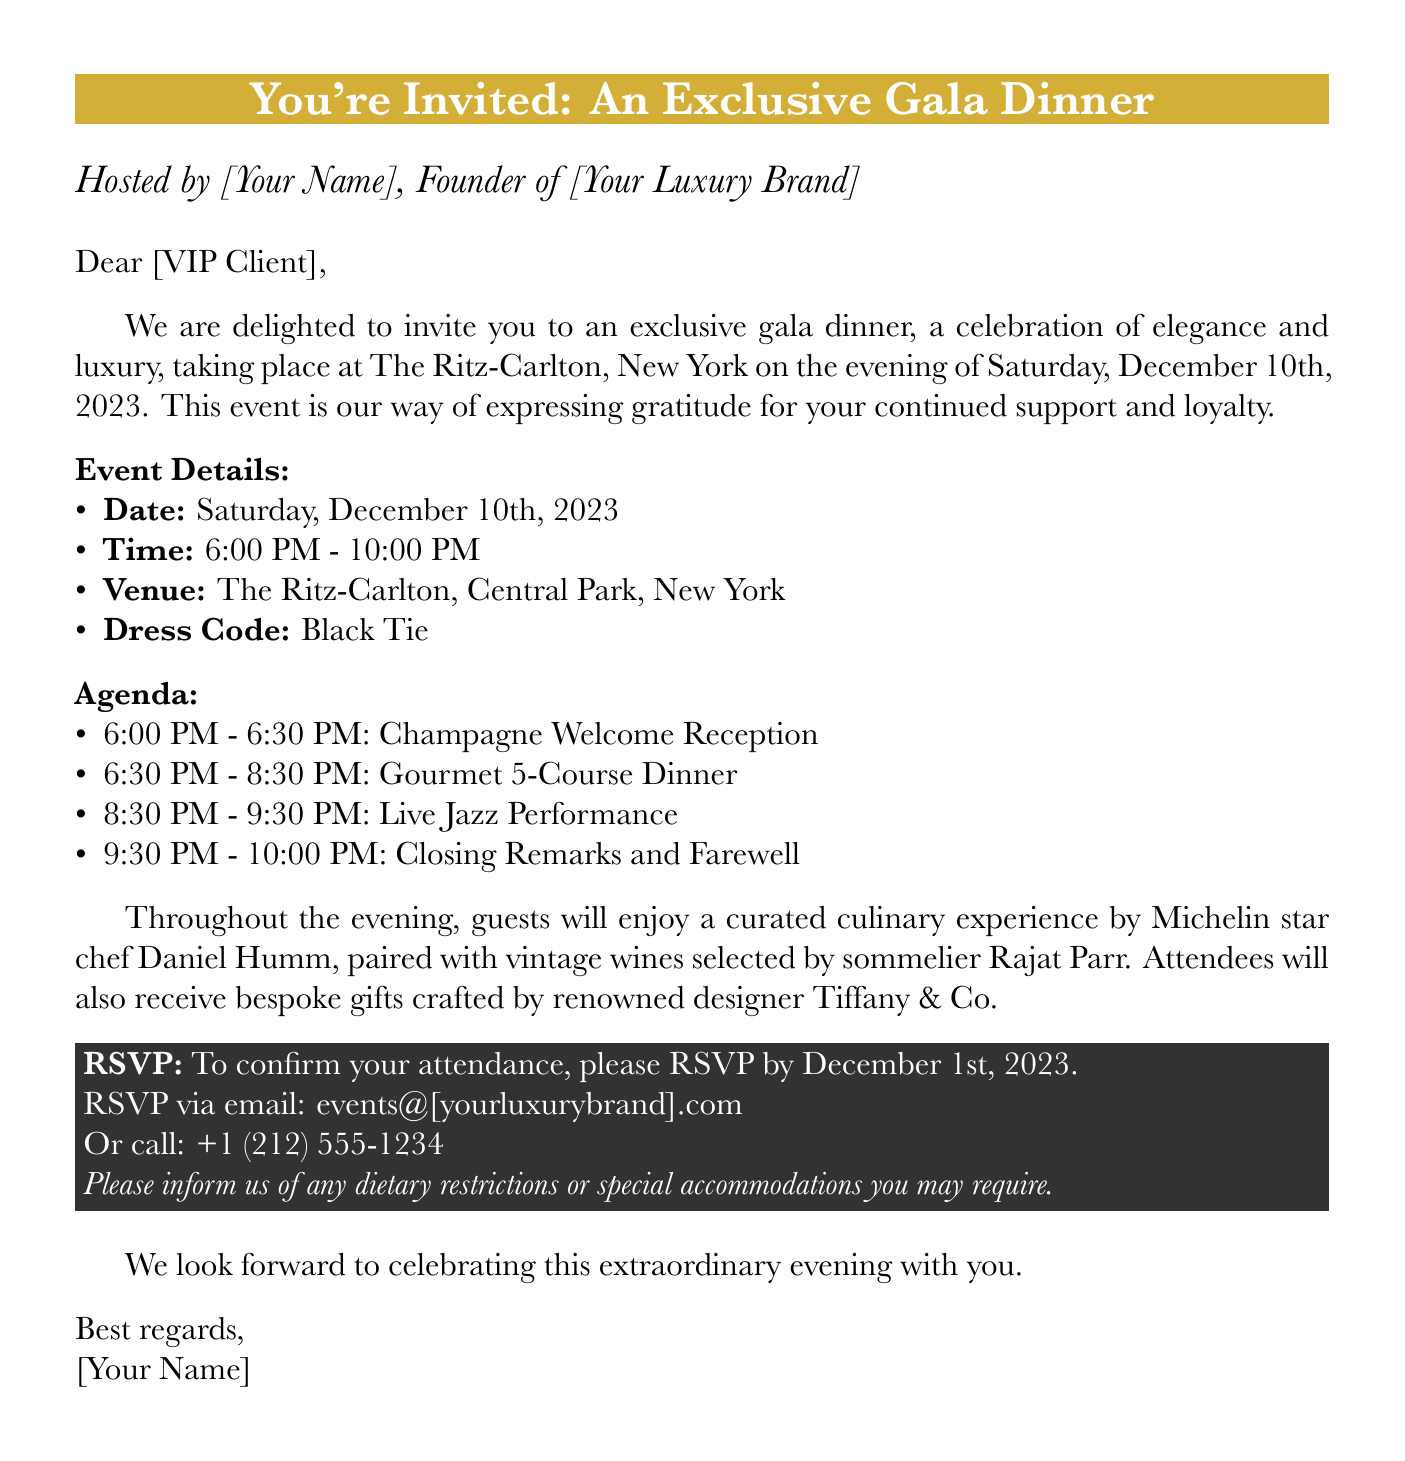what is the date of the event? The date of the exclusive gala dinner is explicitly stated in the document.
Answer: Saturday, December 10th, 2023 what time does the event start? The starting time of the event is mentioned clearly in the document.
Answer: 6:00 PM where is the venue located? The venue for the gala dinner is specified in the event details section.
Answer: The Ritz-Carlton, Central Park, New York what is the dress code? The dress code for the event is presented in the document.
Answer: Black Tie who is the guest chef for the evening? The name of the chef providing the culinary experience is detailed in the document.
Answer: Daniel Humm how long will the dinner be served? The duration of the gourmet dinner is outlined in the agenda section of the document.
Answer: 2 hours what is the RSVP deadline? The deadline for RSVP is mentioned explicitly in the RSVP section of the document.
Answer: December 1st, 2023 what type of performance will be featured during the event? The type of performance planned for the evening is detailed in the agenda.
Answer: Live Jazz Performance what should guests inform about in their RSVP? The document specifies what information guests need to provide when RSVP-ing.
Answer: Dietary restrictions or special accommodations 